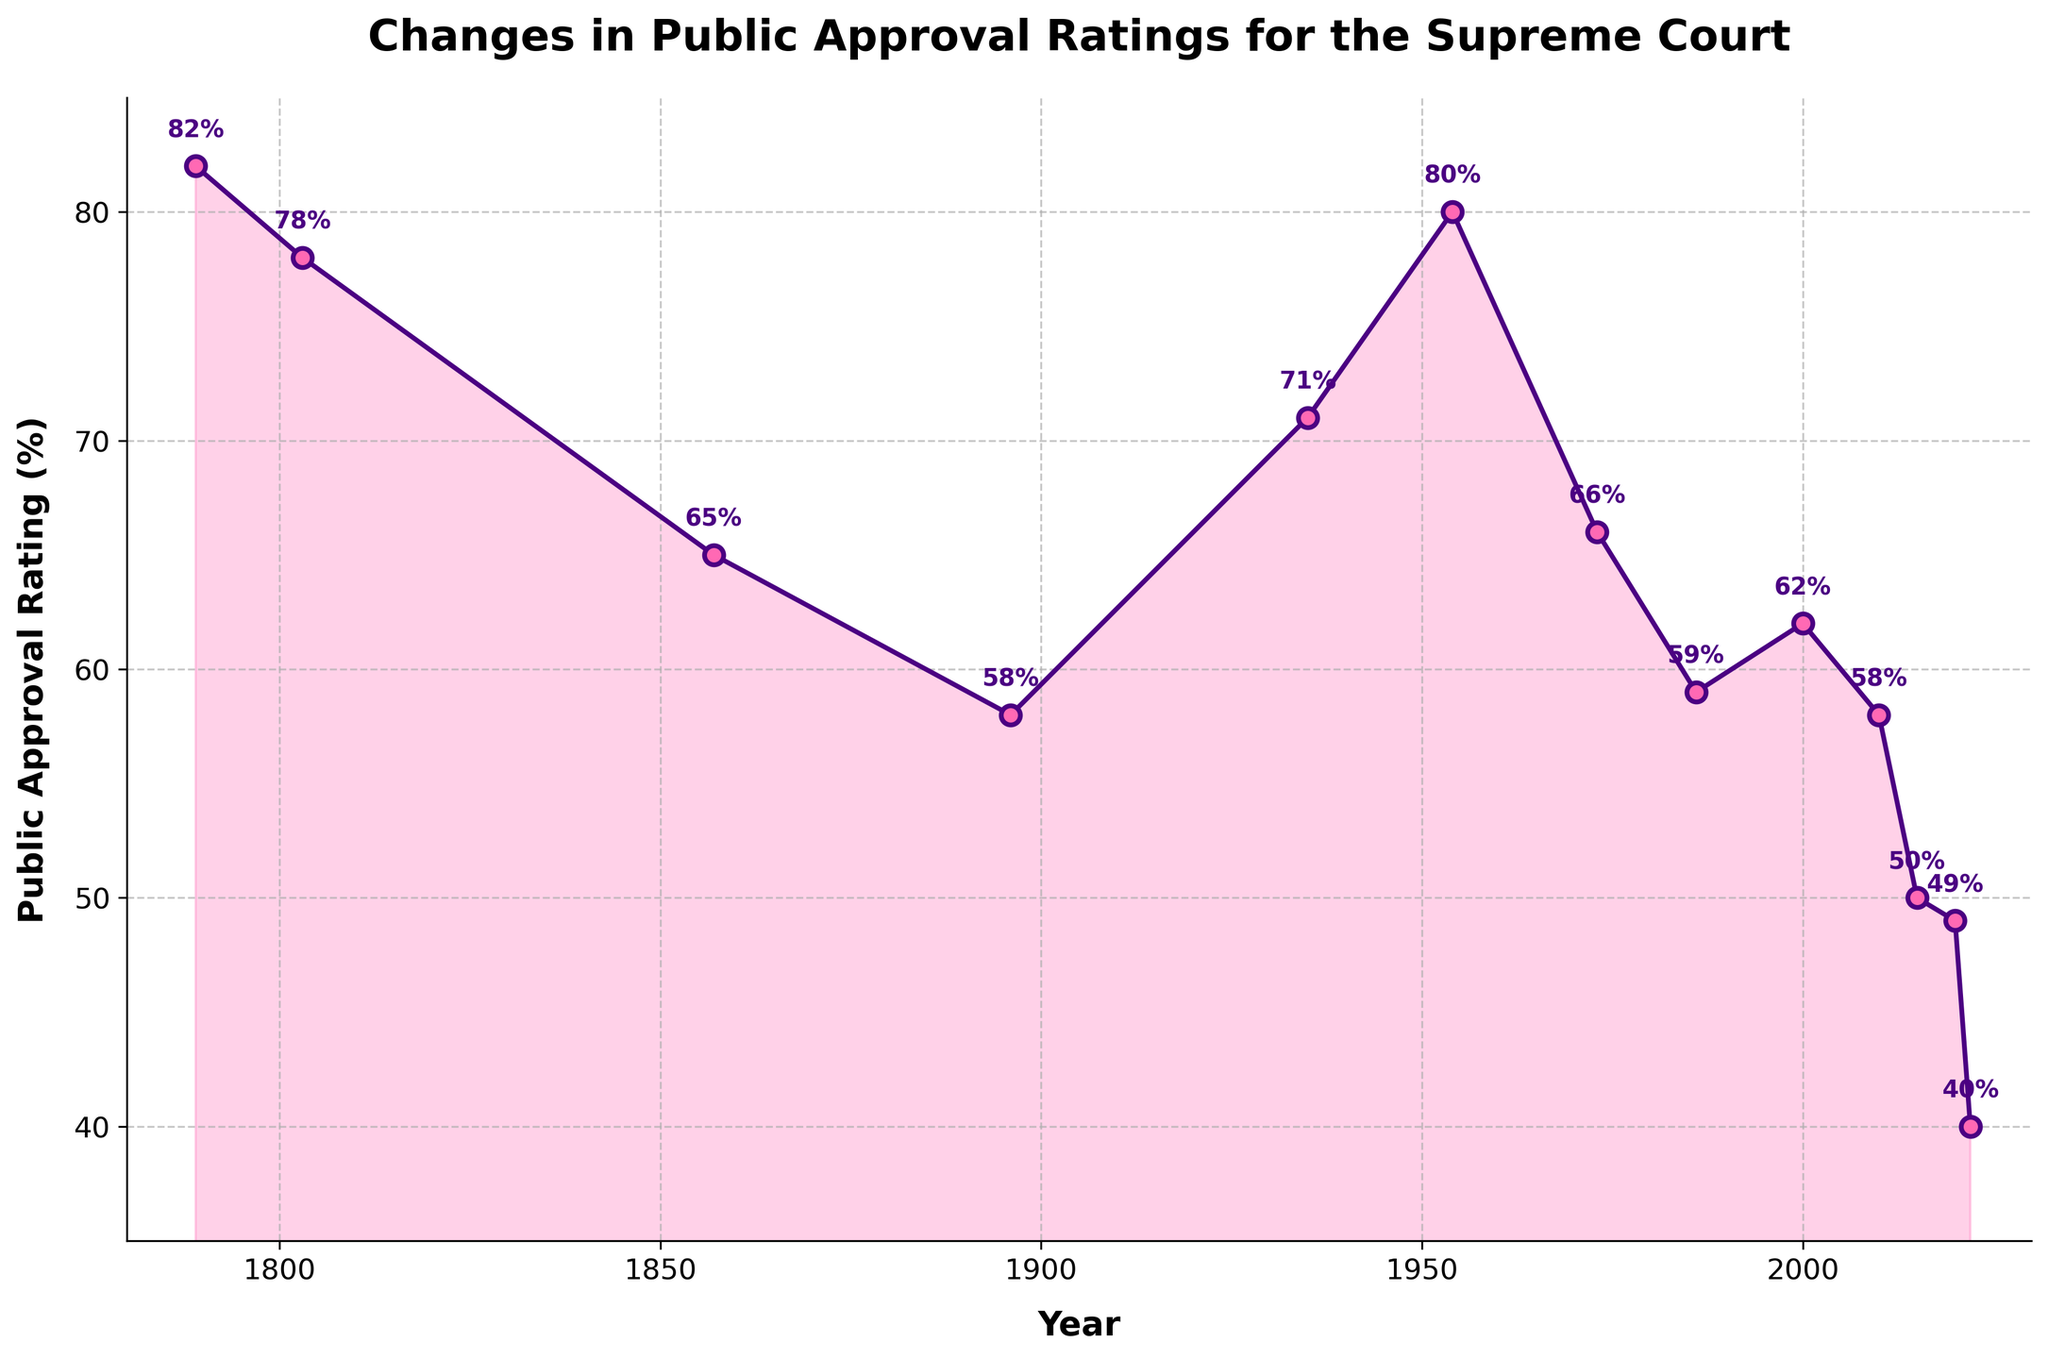What year had the highest public approval rating for the Supreme Court? The highest public approval rating on the chart is 82%. Look for the year associated with this rating.
Answer: 1789 Which year saw the most significant drop in public approval rating compared to the previous data point? Compare the drop in ratings between each year and identify the largest one. The largest drop is between 2010 (58%) and 2015 (50%), resulting in an 8% drop.
Answer: 2015 What is the average public approval rating for the years listed in the figure? Add all the public approval ratings and divide by the number of years listed: (82 + 78 + 65 + 58 + 71 + 80 + 66 + 59 + 62 + 58 + 50 + 49 + 40) / 13 = 61
Answer: 61 How many times did the public approval rating fall below 60%? Count the number of times the approval rating is below 60% in the listed years: 1857, 1896, 1973, 1986, 2000, 2010, 2015, 2020, 2022. There are 9 years.
Answer: 9 Between which consecutive years was there an increase in public approval rating? Identify years where the rating increased compared to the previous year: 1935 (71) to 1954 (80), and 2000 (62) to 2010 (58). Hence, 1935 to 1954.
Answer: 1935-1954 What is the median public approval rating for the years given? Order the approval ratings and find the middle value: The sorted ratings are [40, 49, 50, 58, 58, 59, 62, 65, 66, 71, 78, 80, 82]. The median is the seventh value, which is 62.
Answer: 62 How did the public approval rating change from 1954 to 2022? Compare the rating in 1954 (80%) to the rating in 2022 (40%). There was a decline of 40 percentage points.
Answer: Decreased by 40% Which year had a public approval rating closest to the overall average rating in the figure? First, calculate the average rating as 61%. Find the year with a rating closest to this: 2010 has a rating of 58%, which is closest.
Answer: 2010 What trend can be observed from the changes in public approval ratings over time? The ratings show significant fluctuations, with peaks in the early years and around the mid-20th century, followed by a general decline in recent years. This indicates varying public sentiments over time.
Answer: Fluctuating with a recent decline 